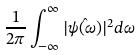Convert formula to latex. <formula><loc_0><loc_0><loc_500><loc_500>\frac { 1 } { 2 \pi } \int _ { - \infty } ^ { \infty } | \hat { \psi ( \omega ) } | ^ { 2 } d \omega</formula> 